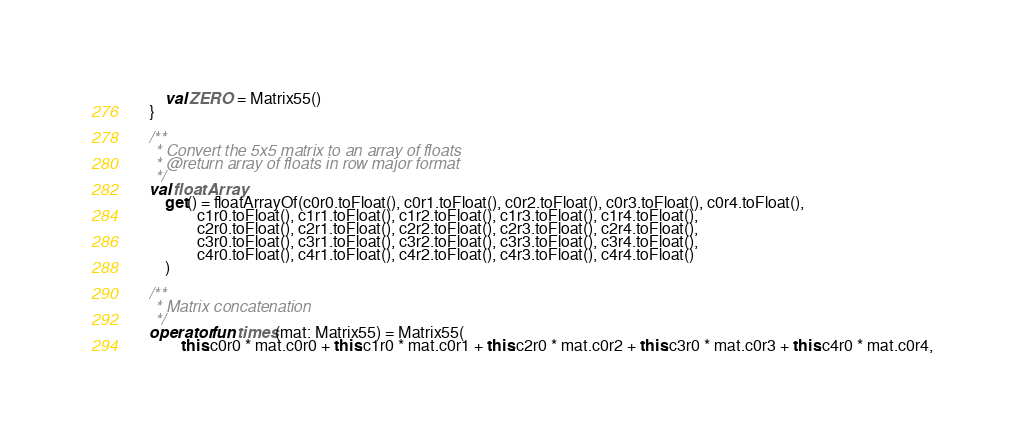Convert code to text. <code><loc_0><loc_0><loc_500><loc_500><_Kotlin_>        val ZERO = Matrix55()
    }

    /**
     * Convert the 5x5 matrix to an array of floats
     * @return array of floats in row major format
     */
    val floatArray
        get() = floatArrayOf(c0r0.toFloat(), c0r1.toFloat(), c0r2.toFloat(), c0r3.toFloat(), c0r4.toFloat(),
                c1r0.toFloat(), c1r1.toFloat(), c1r2.toFloat(), c1r3.toFloat(), c1r4.toFloat(),
                c2r0.toFloat(), c2r1.toFloat(), c2r2.toFloat(), c2r3.toFloat(), c2r4.toFloat(),
                c3r0.toFloat(), c3r1.toFloat(), c3r2.toFloat(), c3r3.toFloat(), c3r4.toFloat(),
                c4r0.toFloat(), c4r1.toFloat(), c4r2.toFloat(), c4r3.toFloat(), c4r4.toFloat()
        )

    /**
     * Matrix concatenation
     */
    operator fun times(mat: Matrix55) = Matrix55(
            this.c0r0 * mat.c0r0 + this.c1r0 * mat.c0r1 + this.c2r0 * mat.c0r2 + this.c3r0 * mat.c0r3 + this.c4r0 * mat.c0r4,</code> 